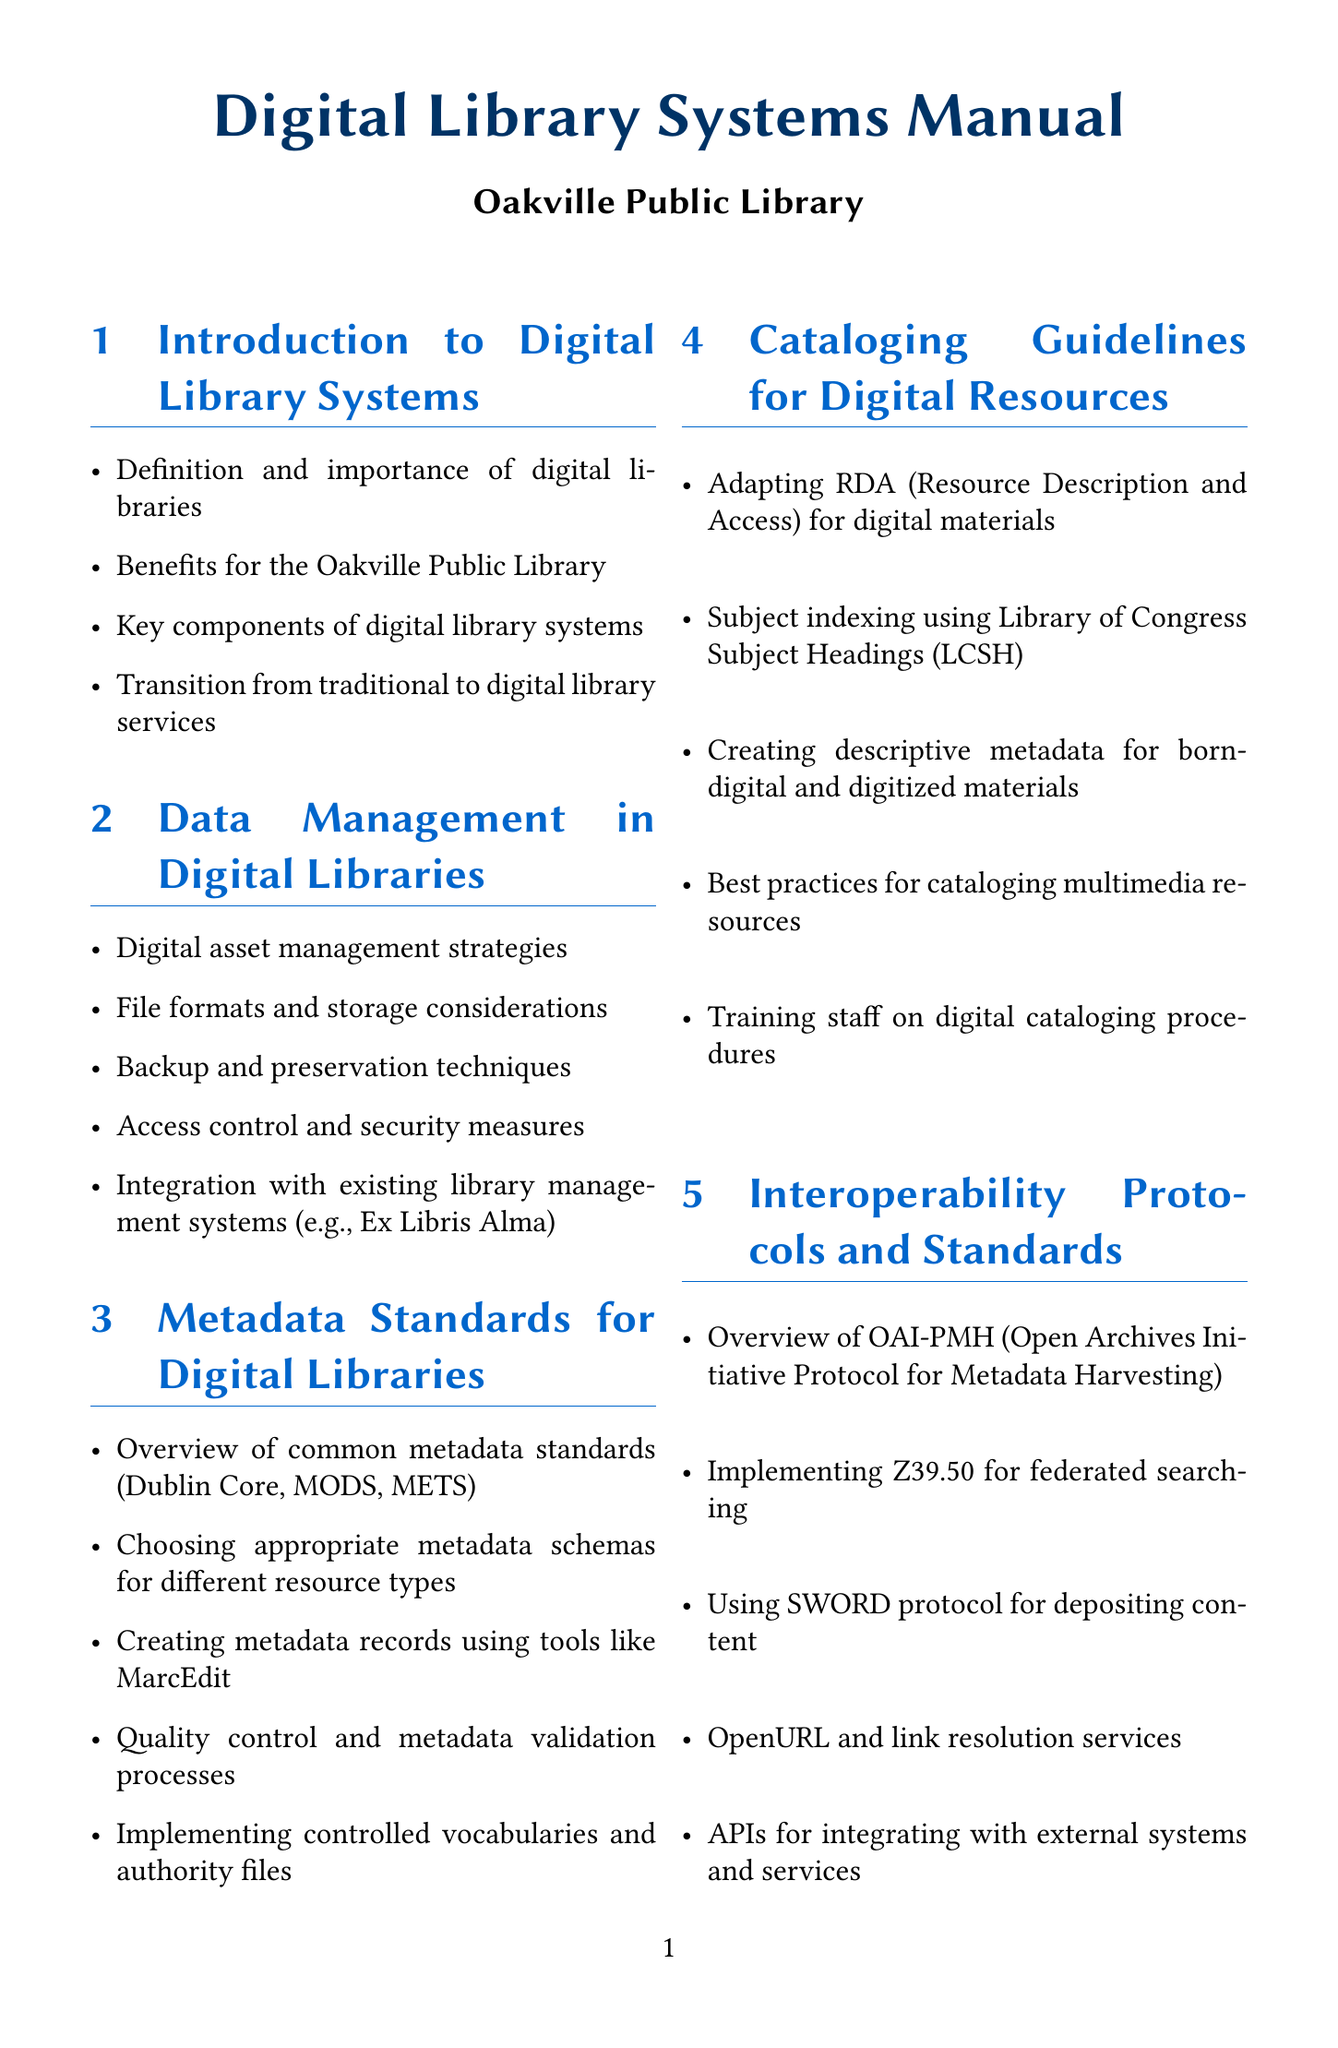What are the key components of digital library systems? The key components of digital library systems are listed in the section titled "Introduction to Digital Library Systems."
Answer: Key components of digital library systems What is the first step in digital preservation planning? The first step in digital preservation planning is mentioned in the section "Digital Preservation Strategies."
Answer: Long-term preservation planning Which metadata standard is often used for describing web resources? The common metadata standards include an overview of standards in the "Metadata Standards for Digital Libraries" section.
Answer: Dublin Core What protocol is used for metadata harvesting? The protocol used for metadata harvesting is found in the "Interoperability Protocols and Standards" section.
Answer: OAI-PMH What does RDA stand for in the context of cataloging? RDA is defined as Resource Description and Access, which is detailed in the "Cataloging Guidelines for Digital Resources" section.
Answer: Resource Description and Access What is the purpose of implementing controlled vocabularies? Controlled vocabularies are discussed in terms of their importance in the "Metadata Standards for Digital Libraries" section.
Answer: Quality control and metadata validation processes What software is suggested for creating metadata records? The suggested tool for creating metadata records is found in the "Metadata Standards for Digital Libraries" section.
Answer: MarcEdit Which digital library system is mentioned for managing institutional repositories? The digital library system for managing institutional repositories is specified in the "Implementing Open Access and Institutional Repositories" section.
Answer: DSpace What is a requirement for ensuring library digital accessibility? The requirement for digital accessibility compliance is mentioned in the "User Interface and Access Considerations" section.
Answer: WCAG 2.1 